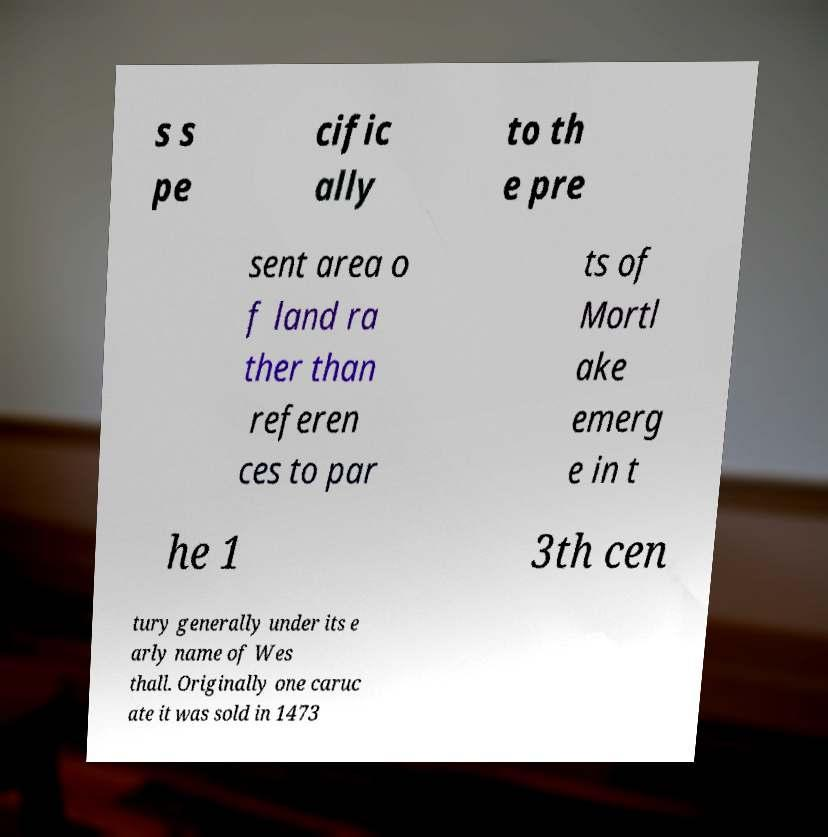Please identify and transcribe the text found in this image. s s pe cific ally to th e pre sent area o f land ra ther than referen ces to par ts of Mortl ake emerg e in t he 1 3th cen tury generally under its e arly name of Wes thall. Originally one caruc ate it was sold in 1473 